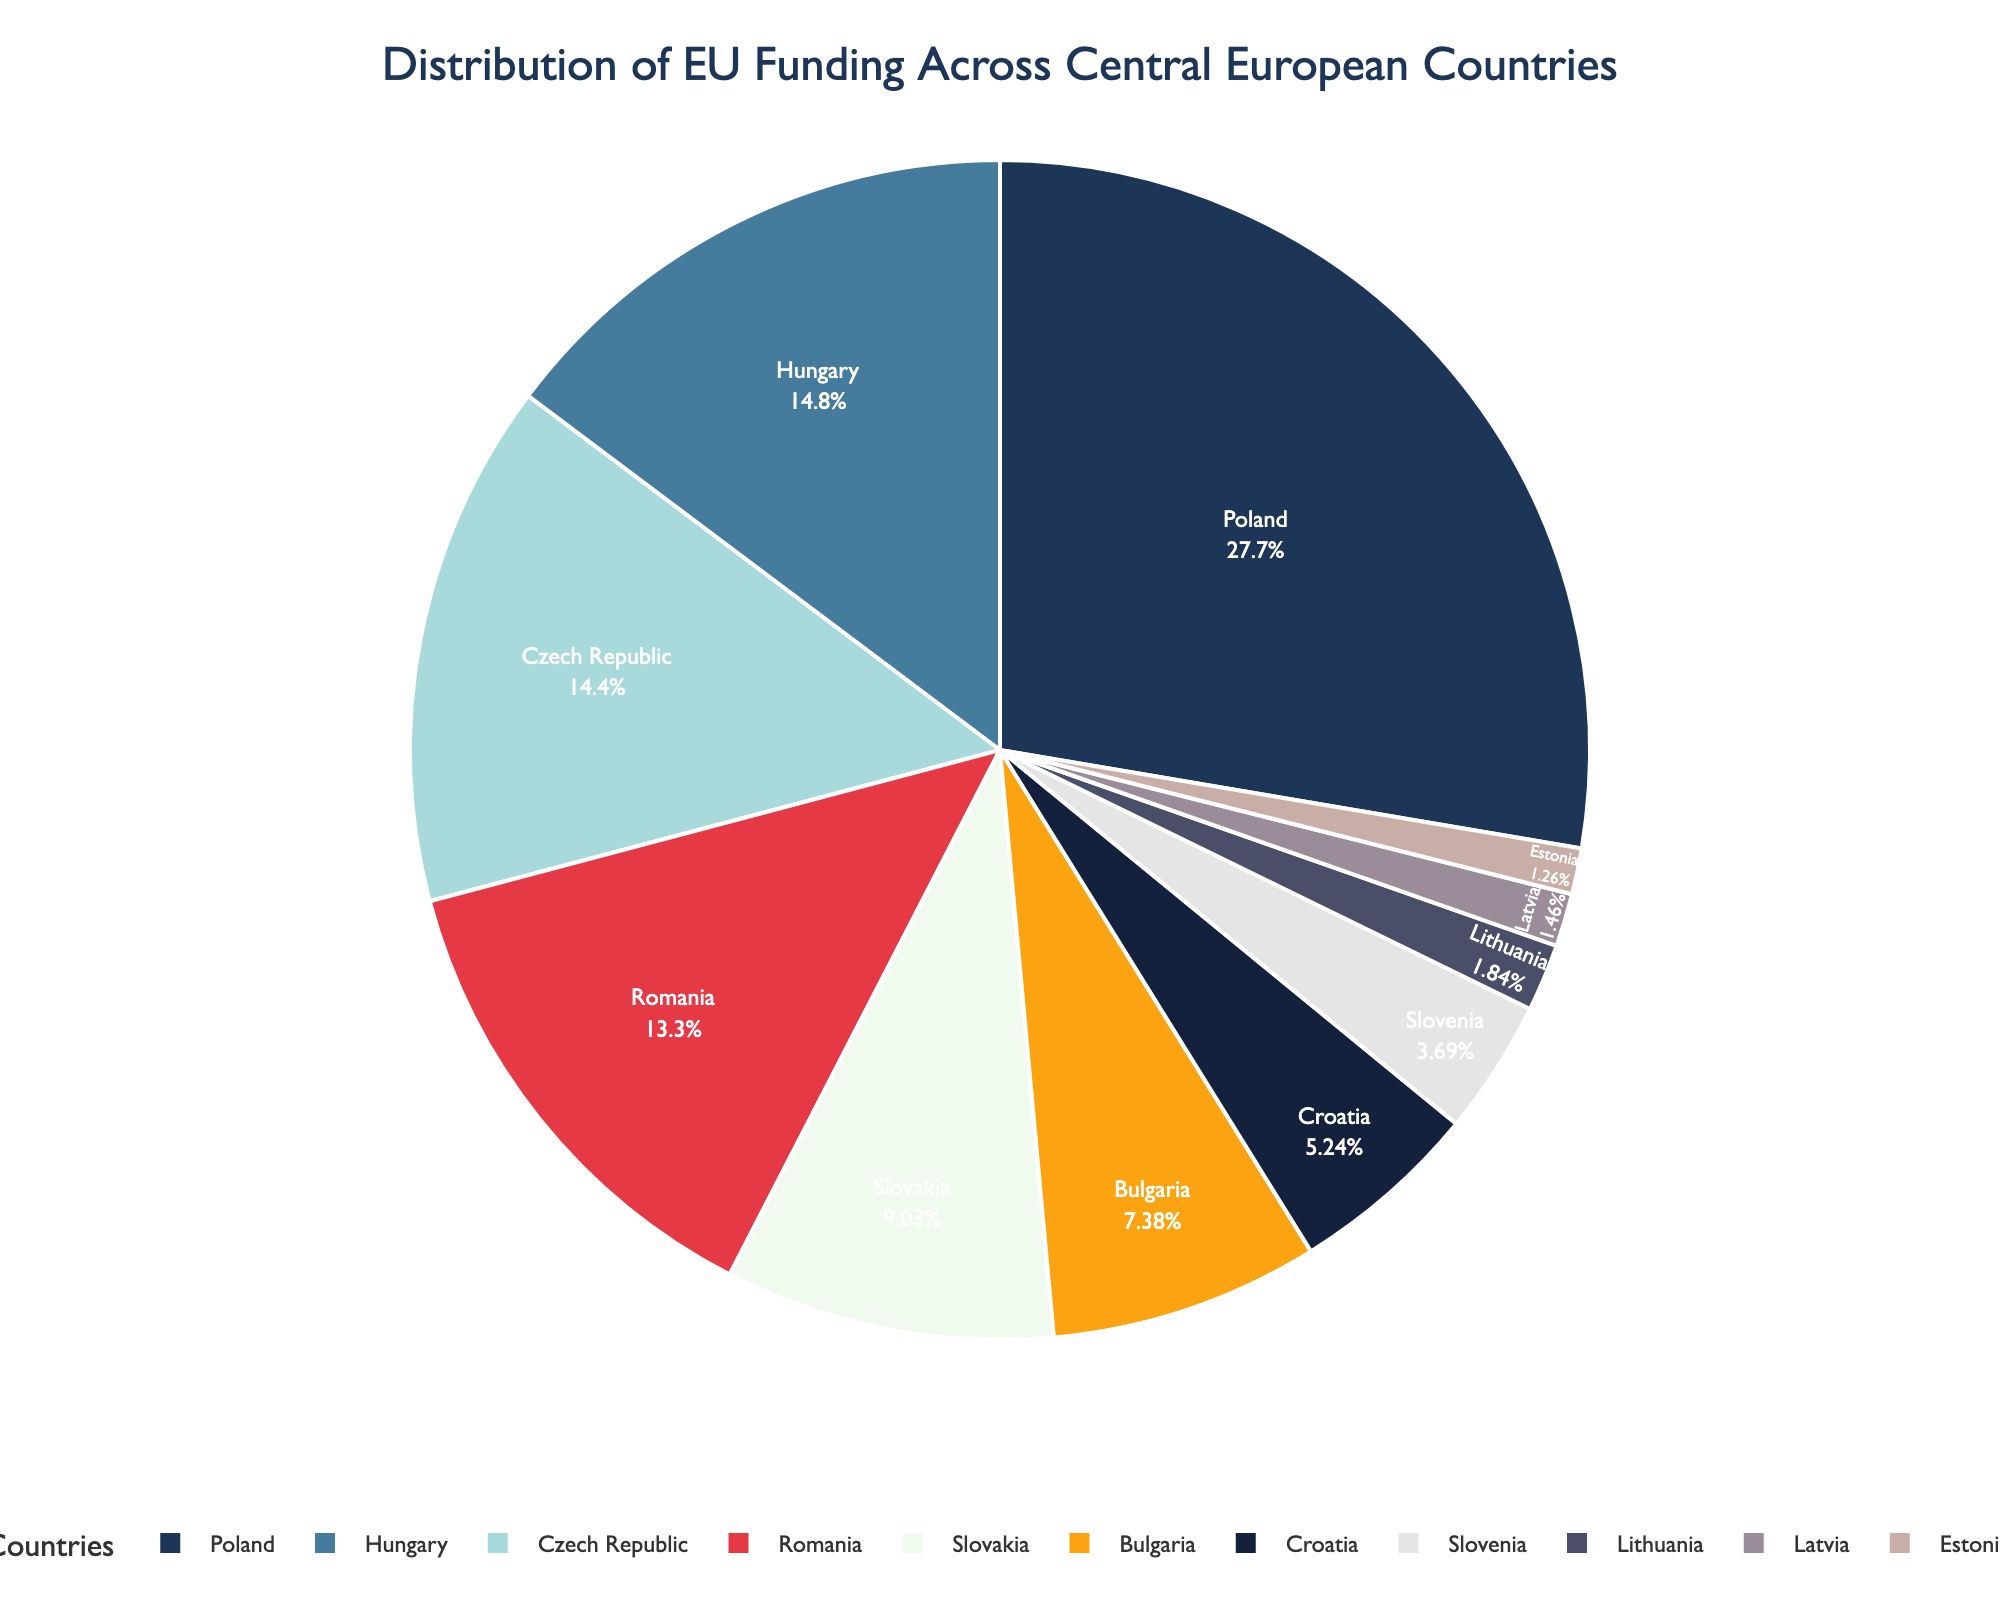Which country receives the highest percentage of EU funding? The pie chart shows that Poland has the largest section, indicating it receives the highest percentage of EU funding.
Answer: Poland How much more percentage of EU funding does Hungary receive compared to Slovakia? Hungary's section shows 15.2%, while Slovakia's shows 9.3%. The difference is calculated by 15.2% - 9.3% = 5.9%.
Answer: 5.9% What is the combined percentage of EU funding for the top three countries? The top three countries are Poland (28.5%), Hungary (15.2%), and Czech Republic (14.8%). Adding these percentages gives 28.5% + 15.2% + 14.8% = 58.5%.
Answer: 58.5% Which country receives a smaller percentage of EU funding: Estonia or Lithuania? Estonia's section shows 1.3%, while Lithuania's shows 1.9%. Therefore, Estonia receives a smaller percentage.
Answer: Estonia What percentage of EU funding is allocated to countries with less than 10% individually? Countries with less than 10% are Lithuania, Latvia, Estonia, Slovenia, Croatia, and Bulgaria, Slovakia. Adding these gives 1.9% + 1.5% + 1.3% + 3.8% + 5.4% + 7.6% + 9.3% = 30.8%.
Answer: 30.8% Which country’s section is represented in yellow? The section of the pie chart colored yellow corresponds to one of the colors defined in the palette, visually appearing in one country's section, which is Croatia (5.4%).
Answer: Croatia Are Romania and Bulgaria combined receiving more EU funding than Hungary? Romania's section shows 13.7% and Bulgaria's section shows 7.6%. Hungary's section shows 15.2%. 13.7% + 7.6% = 21.3% which is greater than 15.2%.
Answer: Yes Which country receives the least percentage of EU funding, and what is the percentage? The pie chart shows that Estonia has the smallest section, indicating it receives the least percentage of EU funding at 1.3%.
Answer: Estonia, 1.3% Rank the top five countries by the percentage of EU funding they receive. The pie chart indicates the rankings visually. The top five countries by percentage are:
1. Poland (28.5%)
2. Hungary (15.2%)
3. Czech Republic (14.8%)
4. Romania (13.7%)
5. Slovakia (9.3%)
Answer: Poland, Hungary, Czech Republic, Romania, Slovakia 